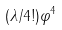<formula> <loc_0><loc_0><loc_500><loc_500>( { \lambda } / { 4 ! } ) \varphi ^ { 4 }</formula> 